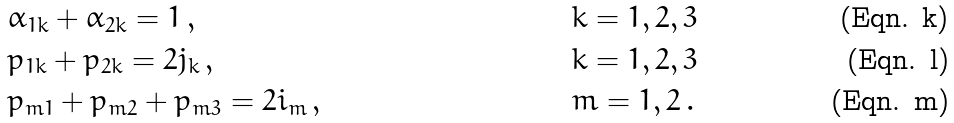<formula> <loc_0><loc_0><loc_500><loc_500>& \alpha _ { 1 k } + \alpha _ { 2 k } = 1 \, , & & k = 1 , 2 , 3 \\ & p _ { 1 k } + p _ { 2 k } = 2 j _ { k } \, , & & k = 1 , 2 , 3 \\ & p _ { m 1 } + p _ { m 2 } + p _ { m 3 } = 2 i _ { m } \, , & & m = 1 , 2 \, .</formula> 